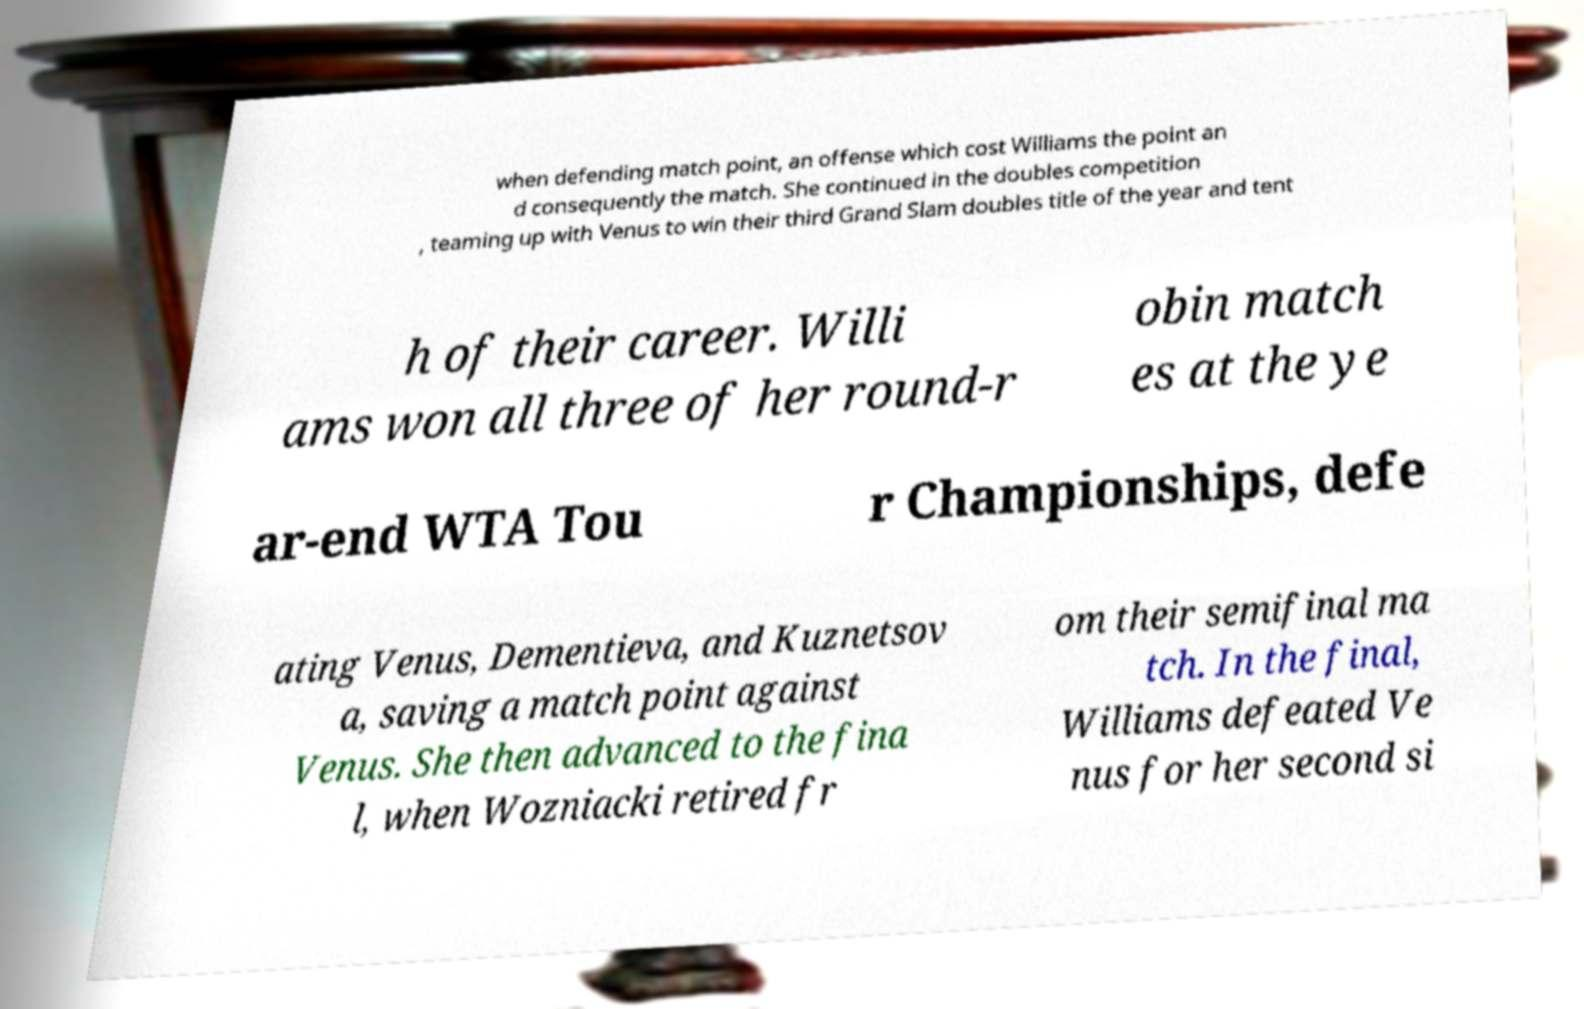Can you accurately transcribe the text from the provided image for me? when defending match point, an offense which cost Williams the point an d consequently the match. She continued in the doubles competition , teaming up with Venus to win their third Grand Slam doubles title of the year and tent h of their career. Willi ams won all three of her round-r obin match es at the ye ar-end WTA Tou r Championships, defe ating Venus, Dementieva, and Kuznetsov a, saving a match point against Venus. She then advanced to the fina l, when Wozniacki retired fr om their semifinal ma tch. In the final, Williams defeated Ve nus for her second si 